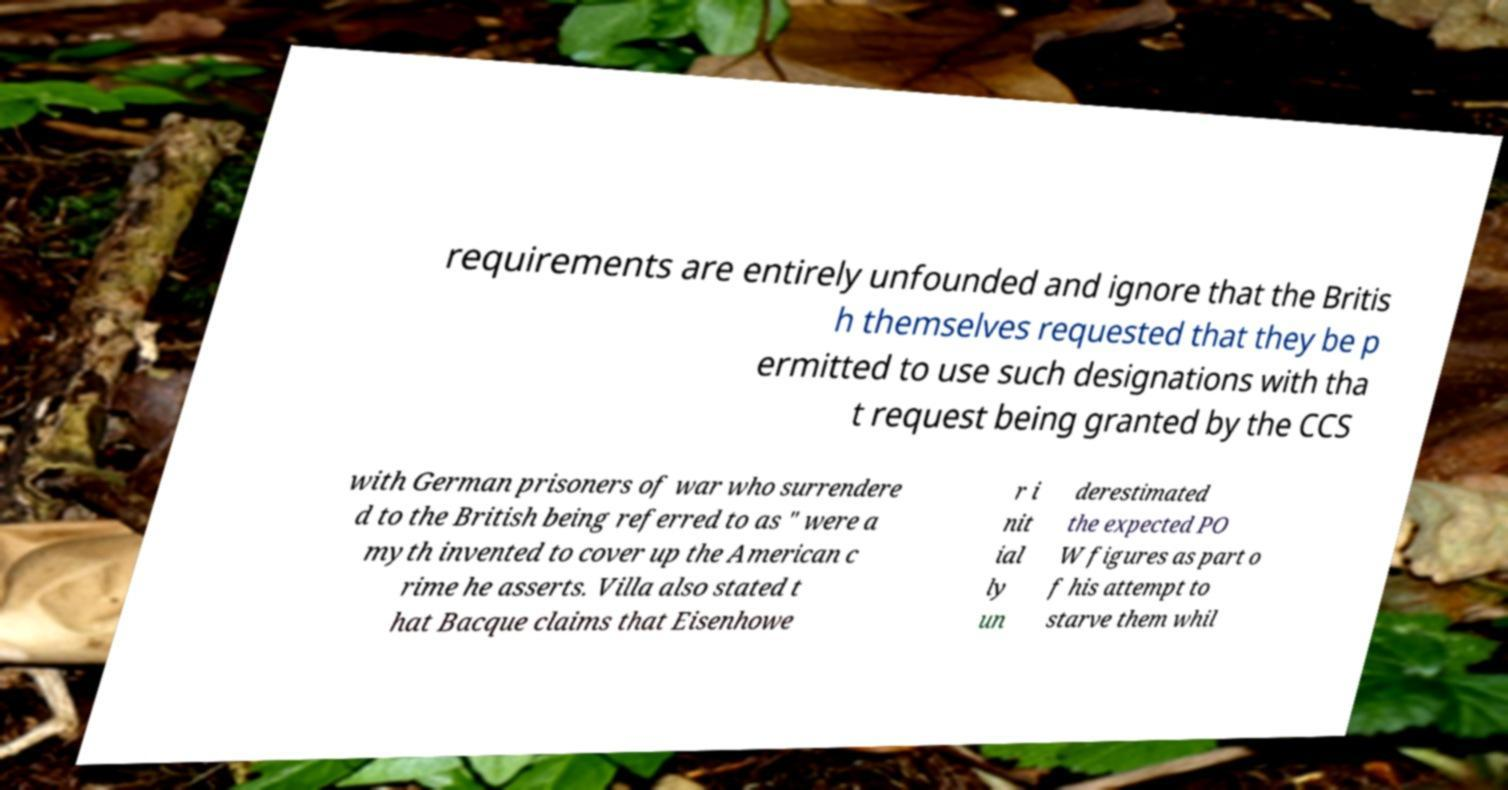There's text embedded in this image that I need extracted. Can you transcribe it verbatim? requirements are entirely unfounded and ignore that the Britis h themselves requested that they be p ermitted to use such designations with tha t request being granted by the CCS with German prisoners of war who surrendere d to the British being referred to as " were a myth invented to cover up the American c rime he asserts. Villa also stated t hat Bacque claims that Eisenhowe r i nit ial ly un derestimated the expected PO W figures as part o f his attempt to starve them whil 